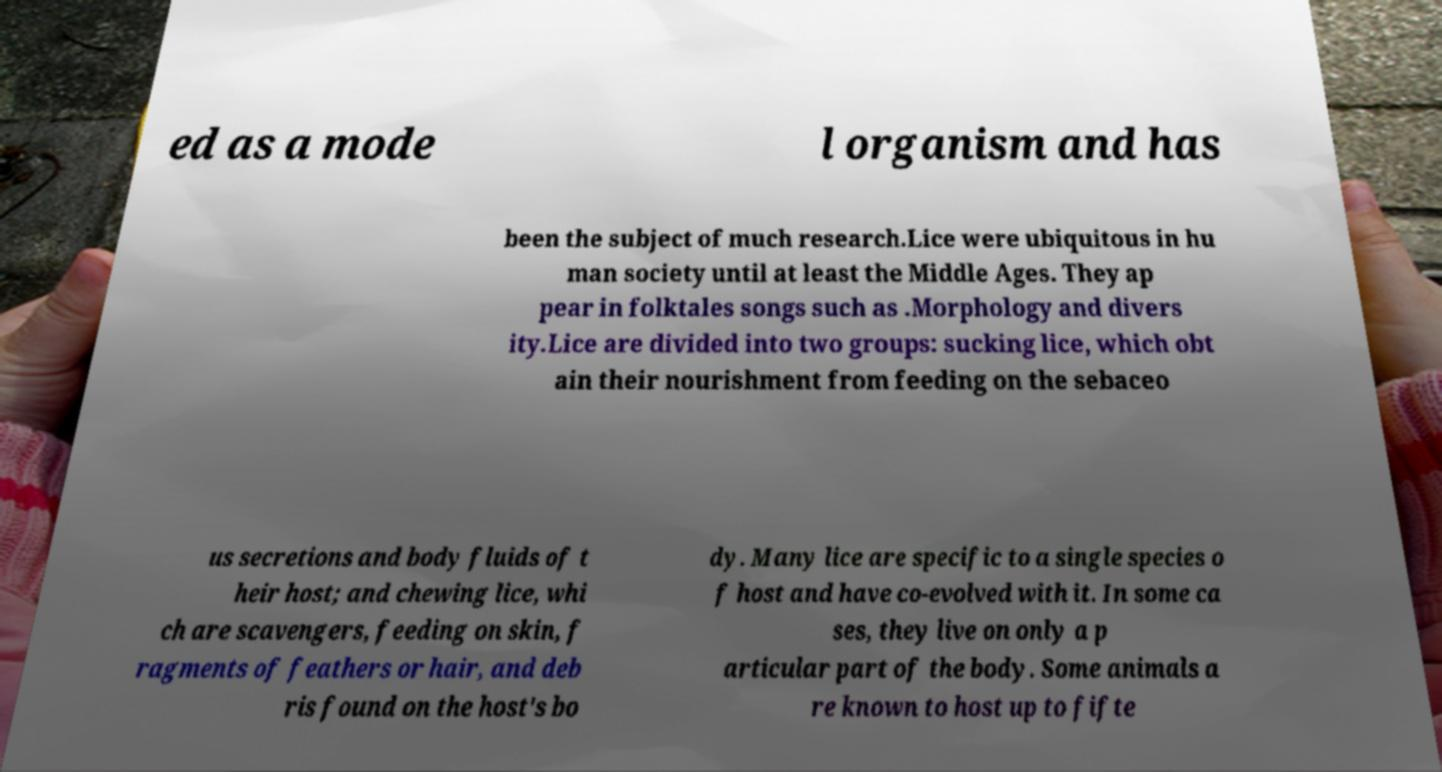I need the written content from this picture converted into text. Can you do that? ed as a mode l organism and has been the subject of much research.Lice were ubiquitous in hu man society until at least the Middle Ages. They ap pear in folktales songs such as .Morphology and divers ity.Lice are divided into two groups: sucking lice, which obt ain their nourishment from feeding on the sebaceo us secretions and body fluids of t heir host; and chewing lice, whi ch are scavengers, feeding on skin, f ragments of feathers or hair, and deb ris found on the host's bo dy. Many lice are specific to a single species o f host and have co-evolved with it. In some ca ses, they live on only a p articular part of the body. Some animals a re known to host up to fifte 